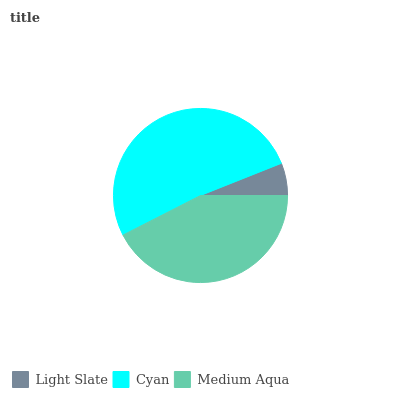Is Light Slate the minimum?
Answer yes or no. Yes. Is Cyan the maximum?
Answer yes or no. Yes. Is Medium Aqua the minimum?
Answer yes or no. No. Is Medium Aqua the maximum?
Answer yes or no. No. Is Cyan greater than Medium Aqua?
Answer yes or no. Yes. Is Medium Aqua less than Cyan?
Answer yes or no. Yes. Is Medium Aqua greater than Cyan?
Answer yes or no. No. Is Cyan less than Medium Aqua?
Answer yes or no. No. Is Medium Aqua the high median?
Answer yes or no. Yes. Is Medium Aqua the low median?
Answer yes or no. Yes. Is Cyan the high median?
Answer yes or no. No. Is Light Slate the low median?
Answer yes or no. No. 